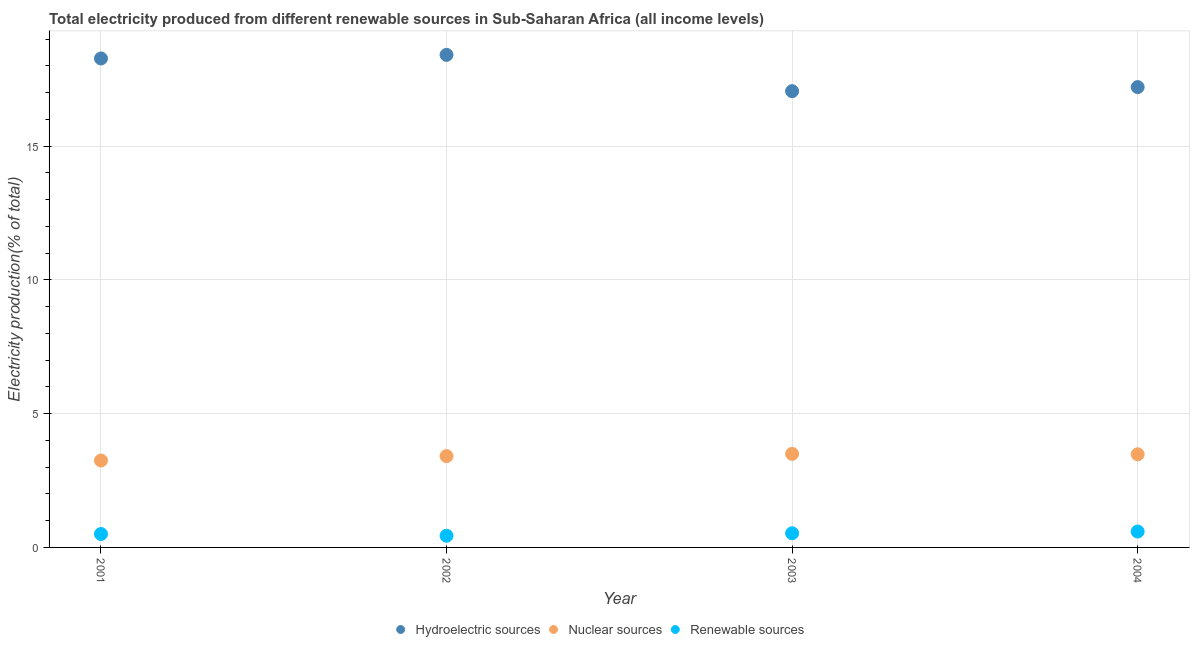How many different coloured dotlines are there?
Offer a very short reply. 3. What is the percentage of electricity produced by renewable sources in 2003?
Provide a short and direct response. 0.53. Across all years, what is the maximum percentage of electricity produced by hydroelectric sources?
Provide a short and direct response. 18.41. Across all years, what is the minimum percentage of electricity produced by hydroelectric sources?
Your answer should be very brief. 17.05. In which year was the percentage of electricity produced by renewable sources minimum?
Your answer should be very brief. 2002. What is the total percentage of electricity produced by renewable sources in the graph?
Make the answer very short. 2.06. What is the difference between the percentage of electricity produced by renewable sources in 2002 and that in 2003?
Your answer should be very brief. -0.09. What is the difference between the percentage of electricity produced by nuclear sources in 2001 and the percentage of electricity produced by renewable sources in 2004?
Your answer should be very brief. 2.65. What is the average percentage of electricity produced by renewable sources per year?
Make the answer very short. 0.52. In the year 2004, what is the difference between the percentage of electricity produced by renewable sources and percentage of electricity produced by nuclear sources?
Your answer should be very brief. -2.89. What is the ratio of the percentage of electricity produced by hydroelectric sources in 2002 to that in 2004?
Give a very brief answer. 1.07. What is the difference between the highest and the second highest percentage of electricity produced by nuclear sources?
Offer a terse response. 0.02. What is the difference between the highest and the lowest percentage of electricity produced by hydroelectric sources?
Ensure brevity in your answer.  1.36. In how many years, is the percentage of electricity produced by nuclear sources greater than the average percentage of electricity produced by nuclear sources taken over all years?
Provide a succinct answer. 3. Is the sum of the percentage of electricity produced by nuclear sources in 2002 and 2004 greater than the maximum percentage of electricity produced by renewable sources across all years?
Your response must be concise. Yes. Does the percentage of electricity produced by nuclear sources monotonically increase over the years?
Offer a very short reply. No. Is the percentage of electricity produced by hydroelectric sources strictly greater than the percentage of electricity produced by nuclear sources over the years?
Give a very brief answer. Yes. Is the percentage of electricity produced by hydroelectric sources strictly less than the percentage of electricity produced by nuclear sources over the years?
Give a very brief answer. No. How many dotlines are there?
Offer a very short reply. 3. How many years are there in the graph?
Offer a terse response. 4. Are the values on the major ticks of Y-axis written in scientific E-notation?
Your answer should be compact. No. Does the graph contain grids?
Ensure brevity in your answer.  Yes. Where does the legend appear in the graph?
Your response must be concise. Bottom center. How many legend labels are there?
Offer a very short reply. 3. What is the title of the graph?
Your response must be concise. Total electricity produced from different renewable sources in Sub-Saharan Africa (all income levels). Does "Liquid fuel" appear as one of the legend labels in the graph?
Offer a very short reply. No. What is the label or title of the Y-axis?
Offer a very short reply. Electricity production(% of total). What is the Electricity production(% of total) in Hydroelectric sources in 2001?
Your response must be concise. 18.27. What is the Electricity production(% of total) in Nuclear sources in 2001?
Your answer should be compact. 3.25. What is the Electricity production(% of total) of Renewable sources in 2001?
Make the answer very short. 0.5. What is the Electricity production(% of total) of Hydroelectric sources in 2002?
Your answer should be very brief. 18.41. What is the Electricity production(% of total) in Nuclear sources in 2002?
Offer a terse response. 3.41. What is the Electricity production(% of total) in Renewable sources in 2002?
Provide a short and direct response. 0.44. What is the Electricity production(% of total) of Hydroelectric sources in 2003?
Ensure brevity in your answer.  17.05. What is the Electricity production(% of total) of Nuclear sources in 2003?
Ensure brevity in your answer.  3.5. What is the Electricity production(% of total) of Renewable sources in 2003?
Ensure brevity in your answer.  0.53. What is the Electricity production(% of total) in Hydroelectric sources in 2004?
Your response must be concise. 17.2. What is the Electricity production(% of total) of Nuclear sources in 2004?
Offer a terse response. 3.48. What is the Electricity production(% of total) of Renewable sources in 2004?
Ensure brevity in your answer.  0.6. Across all years, what is the maximum Electricity production(% of total) in Hydroelectric sources?
Provide a succinct answer. 18.41. Across all years, what is the maximum Electricity production(% of total) in Nuclear sources?
Provide a succinct answer. 3.5. Across all years, what is the maximum Electricity production(% of total) in Renewable sources?
Provide a short and direct response. 0.6. Across all years, what is the minimum Electricity production(% of total) of Hydroelectric sources?
Offer a terse response. 17.05. Across all years, what is the minimum Electricity production(% of total) in Nuclear sources?
Give a very brief answer. 3.25. Across all years, what is the minimum Electricity production(% of total) of Renewable sources?
Keep it short and to the point. 0.44. What is the total Electricity production(% of total) of Hydroelectric sources in the graph?
Your answer should be compact. 70.94. What is the total Electricity production(% of total) of Nuclear sources in the graph?
Offer a very short reply. 13.64. What is the total Electricity production(% of total) of Renewable sources in the graph?
Ensure brevity in your answer.  2.06. What is the difference between the Electricity production(% of total) of Hydroelectric sources in 2001 and that in 2002?
Provide a short and direct response. -0.13. What is the difference between the Electricity production(% of total) of Nuclear sources in 2001 and that in 2002?
Your answer should be compact. -0.17. What is the difference between the Electricity production(% of total) of Renewable sources in 2001 and that in 2002?
Offer a terse response. 0.07. What is the difference between the Electricity production(% of total) of Hydroelectric sources in 2001 and that in 2003?
Provide a short and direct response. 1.22. What is the difference between the Electricity production(% of total) in Nuclear sources in 2001 and that in 2003?
Keep it short and to the point. -0.25. What is the difference between the Electricity production(% of total) of Renewable sources in 2001 and that in 2003?
Provide a succinct answer. -0.03. What is the difference between the Electricity production(% of total) in Hydroelectric sources in 2001 and that in 2004?
Offer a very short reply. 1.07. What is the difference between the Electricity production(% of total) of Nuclear sources in 2001 and that in 2004?
Offer a very short reply. -0.23. What is the difference between the Electricity production(% of total) of Renewable sources in 2001 and that in 2004?
Offer a very short reply. -0.09. What is the difference between the Electricity production(% of total) in Hydroelectric sources in 2002 and that in 2003?
Your response must be concise. 1.36. What is the difference between the Electricity production(% of total) of Nuclear sources in 2002 and that in 2003?
Ensure brevity in your answer.  -0.08. What is the difference between the Electricity production(% of total) of Renewable sources in 2002 and that in 2003?
Offer a very short reply. -0.09. What is the difference between the Electricity production(% of total) of Hydroelectric sources in 2002 and that in 2004?
Offer a terse response. 1.2. What is the difference between the Electricity production(% of total) of Nuclear sources in 2002 and that in 2004?
Make the answer very short. -0.07. What is the difference between the Electricity production(% of total) of Renewable sources in 2002 and that in 2004?
Offer a terse response. -0.16. What is the difference between the Electricity production(% of total) in Hydroelectric sources in 2003 and that in 2004?
Give a very brief answer. -0.15. What is the difference between the Electricity production(% of total) of Nuclear sources in 2003 and that in 2004?
Your answer should be compact. 0.02. What is the difference between the Electricity production(% of total) of Renewable sources in 2003 and that in 2004?
Offer a terse response. -0.07. What is the difference between the Electricity production(% of total) in Hydroelectric sources in 2001 and the Electricity production(% of total) in Nuclear sources in 2002?
Keep it short and to the point. 14.86. What is the difference between the Electricity production(% of total) of Hydroelectric sources in 2001 and the Electricity production(% of total) of Renewable sources in 2002?
Your response must be concise. 17.84. What is the difference between the Electricity production(% of total) of Nuclear sources in 2001 and the Electricity production(% of total) of Renewable sources in 2002?
Your answer should be very brief. 2.81. What is the difference between the Electricity production(% of total) in Hydroelectric sources in 2001 and the Electricity production(% of total) in Nuclear sources in 2003?
Ensure brevity in your answer.  14.78. What is the difference between the Electricity production(% of total) of Hydroelectric sources in 2001 and the Electricity production(% of total) of Renewable sources in 2003?
Your response must be concise. 17.75. What is the difference between the Electricity production(% of total) in Nuclear sources in 2001 and the Electricity production(% of total) in Renewable sources in 2003?
Your answer should be very brief. 2.72. What is the difference between the Electricity production(% of total) in Hydroelectric sources in 2001 and the Electricity production(% of total) in Nuclear sources in 2004?
Offer a terse response. 14.79. What is the difference between the Electricity production(% of total) in Hydroelectric sources in 2001 and the Electricity production(% of total) in Renewable sources in 2004?
Your response must be concise. 17.68. What is the difference between the Electricity production(% of total) of Nuclear sources in 2001 and the Electricity production(% of total) of Renewable sources in 2004?
Offer a very short reply. 2.65. What is the difference between the Electricity production(% of total) in Hydroelectric sources in 2002 and the Electricity production(% of total) in Nuclear sources in 2003?
Give a very brief answer. 14.91. What is the difference between the Electricity production(% of total) in Hydroelectric sources in 2002 and the Electricity production(% of total) in Renewable sources in 2003?
Provide a short and direct response. 17.88. What is the difference between the Electricity production(% of total) in Nuclear sources in 2002 and the Electricity production(% of total) in Renewable sources in 2003?
Give a very brief answer. 2.88. What is the difference between the Electricity production(% of total) of Hydroelectric sources in 2002 and the Electricity production(% of total) of Nuclear sources in 2004?
Provide a succinct answer. 14.93. What is the difference between the Electricity production(% of total) of Hydroelectric sources in 2002 and the Electricity production(% of total) of Renewable sources in 2004?
Offer a very short reply. 17.81. What is the difference between the Electricity production(% of total) in Nuclear sources in 2002 and the Electricity production(% of total) in Renewable sources in 2004?
Your answer should be very brief. 2.82. What is the difference between the Electricity production(% of total) in Hydroelectric sources in 2003 and the Electricity production(% of total) in Nuclear sources in 2004?
Your answer should be very brief. 13.57. What is the difference between the Electricity production(% of total) in Hydroelectric sources in 2003 and the Electricity production(% of total) in Renewable sources in 2004?
Offer a very short reply. 16.46. What is the difference between the Electricity production(% of total) of Nuclear sources in 2003 and the Electricity production(% of total) of Renewable sources in 2004?
Offer a terse response. 2.9. What is the average Electricity production(% of total) in Hydroelectric sources per year?
Provide a short and direct response. 17.74. What is the average Electricity production(% of total) in Nuclear sources per year?
Offer a very short reply. 3.41. What is the average Electricity production(% of total) in Renewable sources per year?
Make the answer very short. 0.52. In the year 2001, what is the difference between the Electricity production(% of total) in Hydroelectric sources and Electricity production(% of total) in Nuclear sources?
Ensure brevity in your answer.  15.03. In the year 2001, what is the difference between the Electricity production(% of total) of Hydroelectric sources and Electricity production(% of total) of Renewable sources?
Give a very brief answer. 17.77. In the year 2001, what is the difference between the Electricity production(% of total) in Nuclear sources and Electricity production(% of total) in Renewable sources?
Offer a very short reply. 2.75. In the year 2002, what is the difference between the Electricity production(% of total) of Hydroelectric sources and Electricity production(% of total) of Nuclear sources?
Offer a terse response. 15. In the year 2002, what is the difference between the Electricity production(% of total) in Hydroelectric sources and Electricity production(% of total) in Renewable sources?
Offer a terse response. 17.97. In the year 2002, what is the difference between the Electricity production(% of total) in Nuclear sources and Electricity production(% of total) in Renewable sources?
Your answer should be compact. 2.98. In the year 2003, what is the difference between the Electricity production(% of total) of Hydroelectric sources and Electricity production(% of total) of Nuclear sources?
Your answer should be very brief. 13.56. In the year 2003, what is the difference between the Electricity production(% of total) of Hydroelectric sources and Electricity production(% of total) of Renewable sources?
Provide a short and direct response. 16.52. In the year 2003, what is the difference between the Electricity production(% of total) of Nuclear sources and Electricity production(% of total) of Renewable sources?
Offer a very short reply. 2.97. In the year 2004, what is the difference between the Electricity production(% of total) in Hydroelectric sources and Electricity production(% of total) in Nuclear sources?
Give a very brief answer. 13.72. In the year 2004, what is the difference between the Electricity production(% of total) in Hydroelectric sources and Electricity production(% of total) in Renewable sources?
Keep it short and to the point. 16.61. In the year 2004, what is the difference between the Electricity production(% of total) of Nuclear sources and Electricity production(% of total) of Renewable sources?
Your answer should be compact. 2.89. What is the ratio of the Electricity production(% of total) of Hydroelectric sources in 2001 to that in 2002?
Make the answer very short. 0.99. What is the ratio of the Electricity production(% of total) in Nuclear sources in 2001 to that in 2002?
Provide a succinct answer. 0.95. What is the ratio of the Electricity production(% of total) of Renewable sources in 2001 to that in 2002?
Provide a succinct answer. 1.15. What is the ratio of the Electricity production(% of total) of Hydroelectric sources in 2001 to that in 2003?
Offer a terse response. 1.07. What is the ratio of the Electricity production(% of total) of Nuclear sources in 2001 to that in 2003?
Your answer should be compact. 0.93. What is the ratio of the Electricity production(% of total) of Renewable sources in 2001 to that in 2003?
Keep it short and to the point. 0.95. What is the ratio of the Electricity production(% of total) of Hydroelectric sources in 2001 to that in 2004?
Ensure brevity in your answer.  1.06. What is the ratio of the Electricity production(% of total) in Nuclear sources in 2001 to that in 2004?
Keep it short and to the point. 0.93. What is the ratio of the Electricity production(% of total) in Renewable sources in 2001 to that in 2004?
Your answer should be very brief. 0.84. What is the ratio of the Electricity production(% of total) in Hydroelectric sources in 2002 to that in 2003?
Your response must be concise. 1.08. What is the ratio of the Electricity production(% of total) of Nuclear sources in 2002 to that in 2003?
Offer a very short reply. 0.98. What is the ratio of the Electricity production(% of total) in Renewable sources in 2002 to that in 2003?
Keep it short and to the point. 0.82. What is the ratio of the Electricity production(% of total) in Hydroelectric sources in 2002 to that in 2004?
Give a very brief answer. 1.07. What is the ratio of the Electricity production(% of total) in Nuclear sources in 2002 to that in 2004?
Provide a succinct answer. 0.98. What is the ratio of the Electricity production(% of total) of Renewable sources in 2002 to that in 2004?
Your answer should be very brief. 0.73. What is the ratio of the Electricity production(% of total) in Nuclear sources in 2003 to that in 2004?
Your answer should be compact. 1. What is the ratio of the Electricity production(% of total) in Renewable sources in 2003 to that in 2004?
Offer a terse response. 0.89. What is the difference between the highest and the second highest Electricity production(% of total) in Hydroelectric sources?
Keep it short and to the point. 0.13. What is the difference between the highest and the second highest Electricity production(% of total) of Nuclear sources?
Give a very brief answer. 0.02. What is the difference between the highest and the second highest Electricity production(% of total) in Renewable sources?
Provide a short and direct response. 0.07. What is the difference between the highest and the lowest Electricity production(% of total) of Hydroelectric sources?
Your answer should be very brief. 1.36. What is the difference between the highest and the lowest Electricity production(% of total) in Nuclear sources?
Provide a succinct answer. 0.25. What is the difference between the highest and the lowest Electricity production(% of total) in Renewable sources?
Provide a succinct answer. 0.16. 